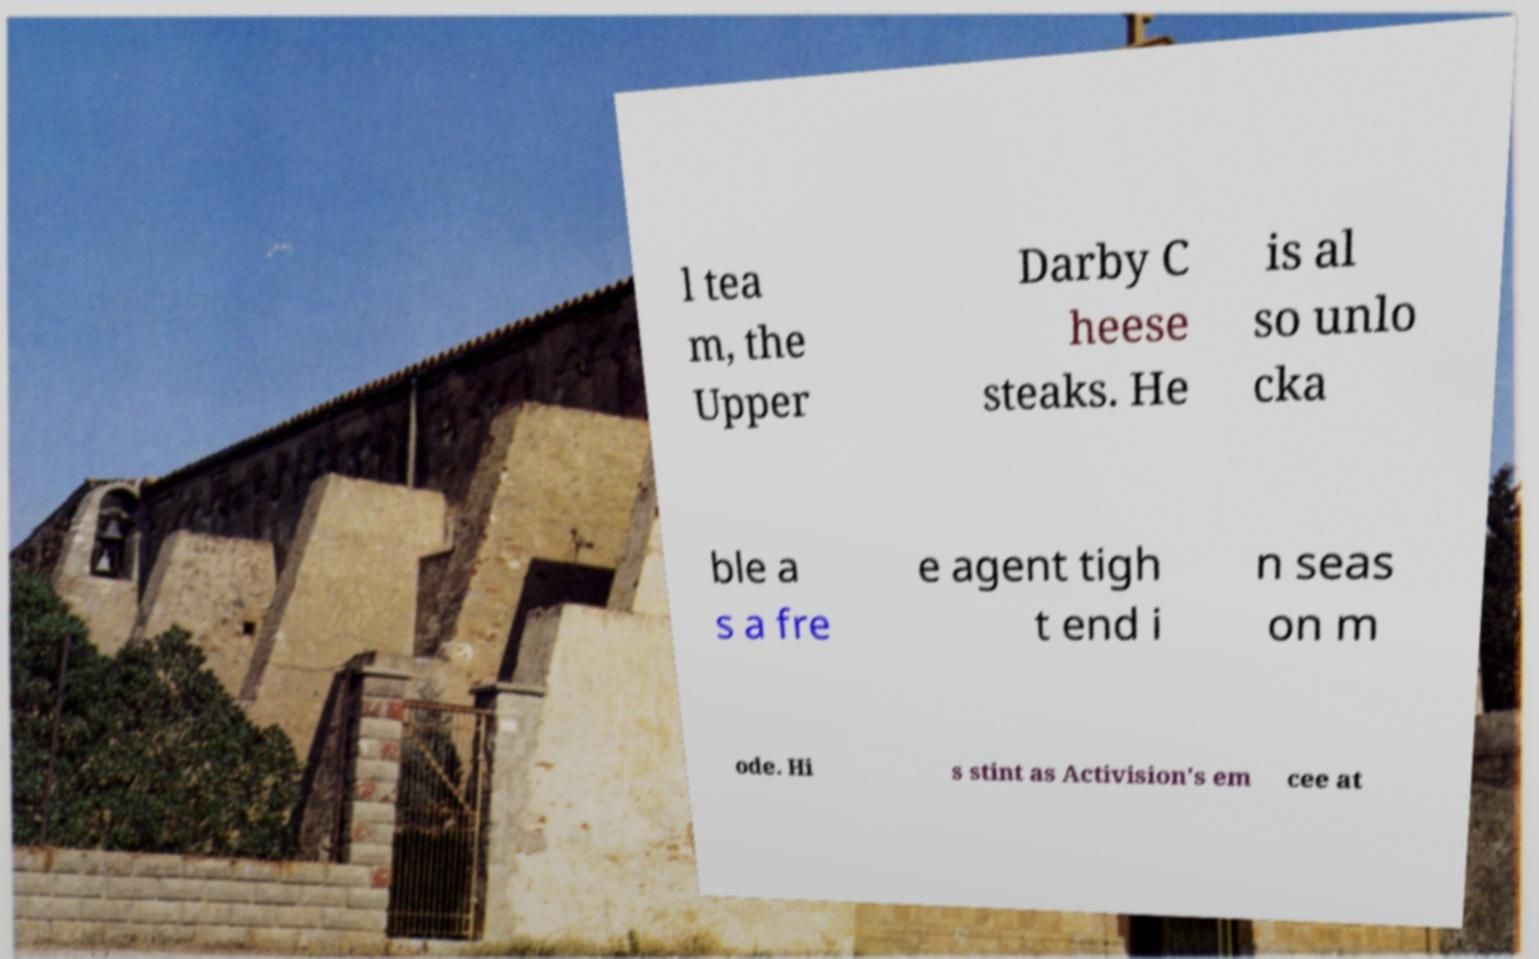Can you accurately transcribe the text from the provided image for me? l tea m, the Upper Darby C heese steaks. He is al so unlo cka ble a s a fre e agent tigh t end i n seas on m ode. Hi s stint as Activision's em cee at 